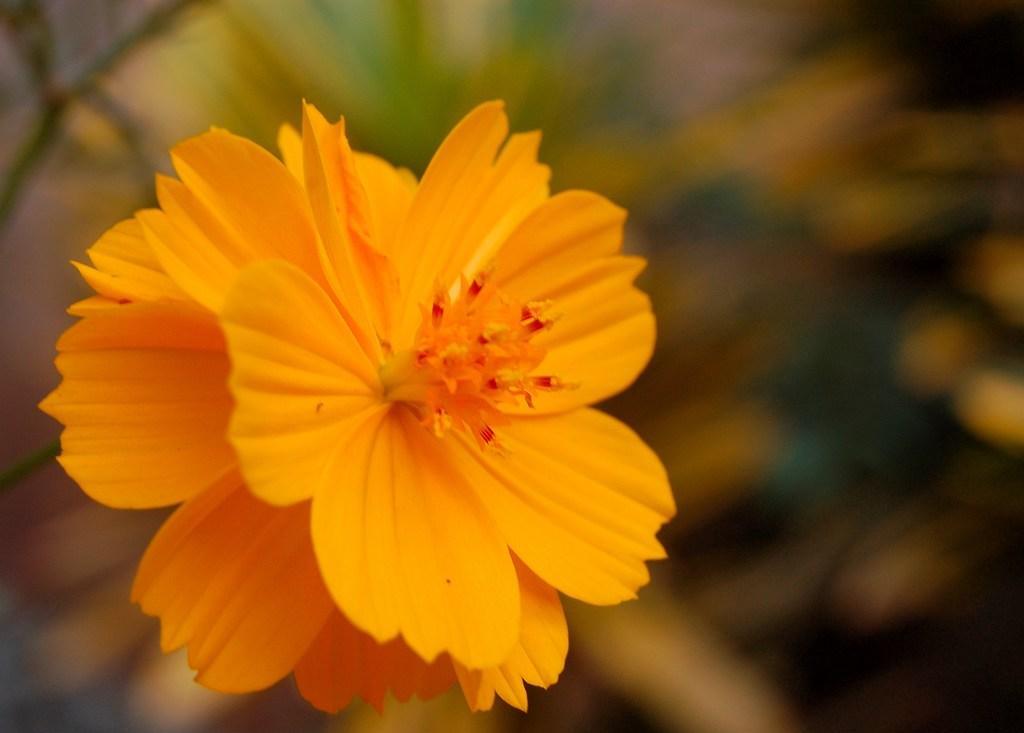How would you summarize this image in a sentence or two? In this picture we can see a flower and blurry background. 